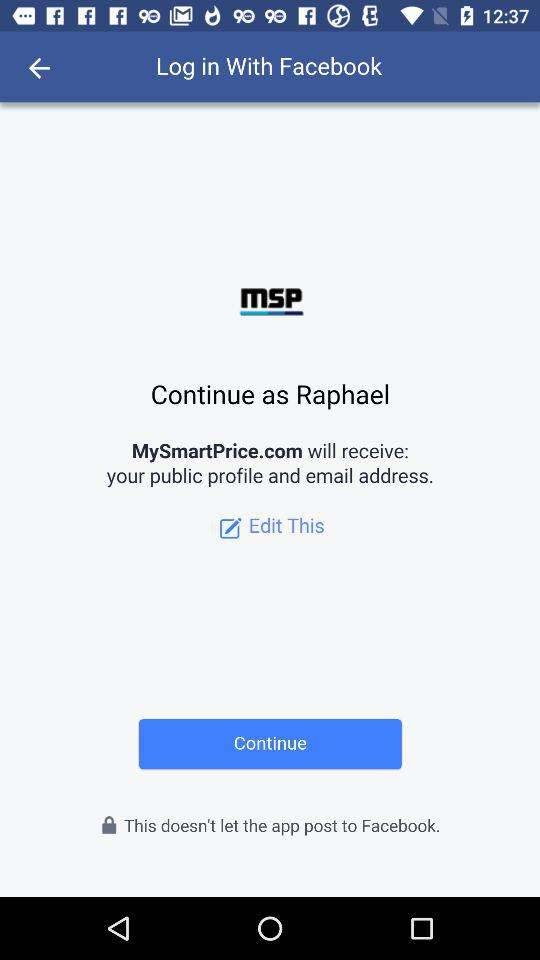What application will receive my public profile and email address? The application "MySmartPrice.com" will receive your public profile and email address. 